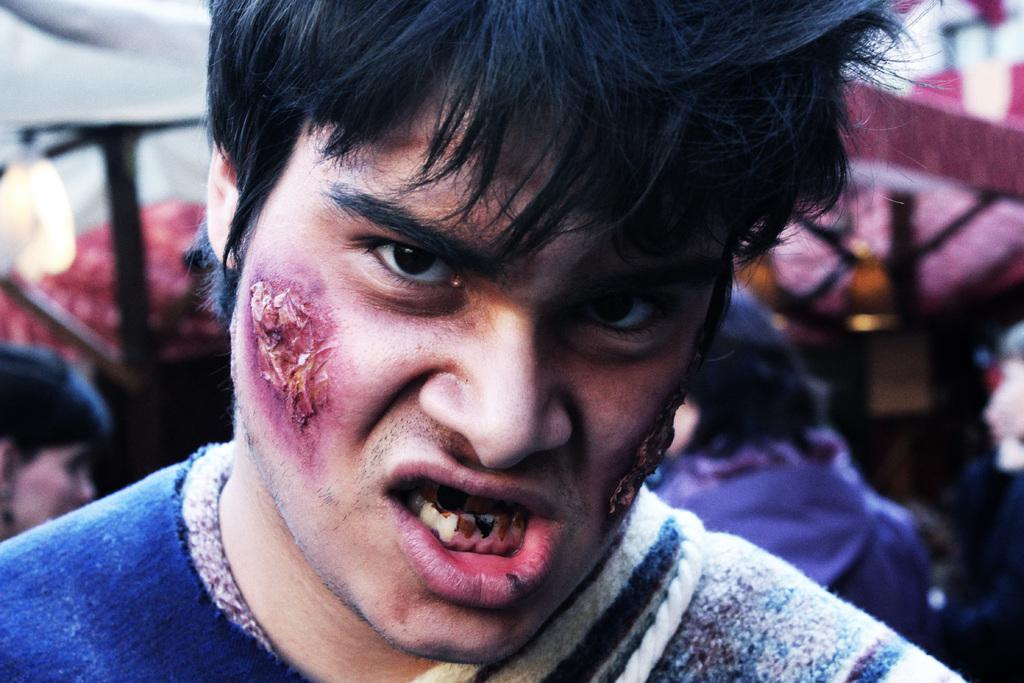Who is the main subject in the image? There is a man in the image. Can you describe the background of the image? The background of the image is blurred. Are there any other people visible in the image? Yes, there are few persons visible in the background. What else can be seen in the background of the image? There are objects visible in the background. What type of insurance policy do the sisters in the image have? There are no sisters present in the image, and therefore, no insurance policy can be discussed. 